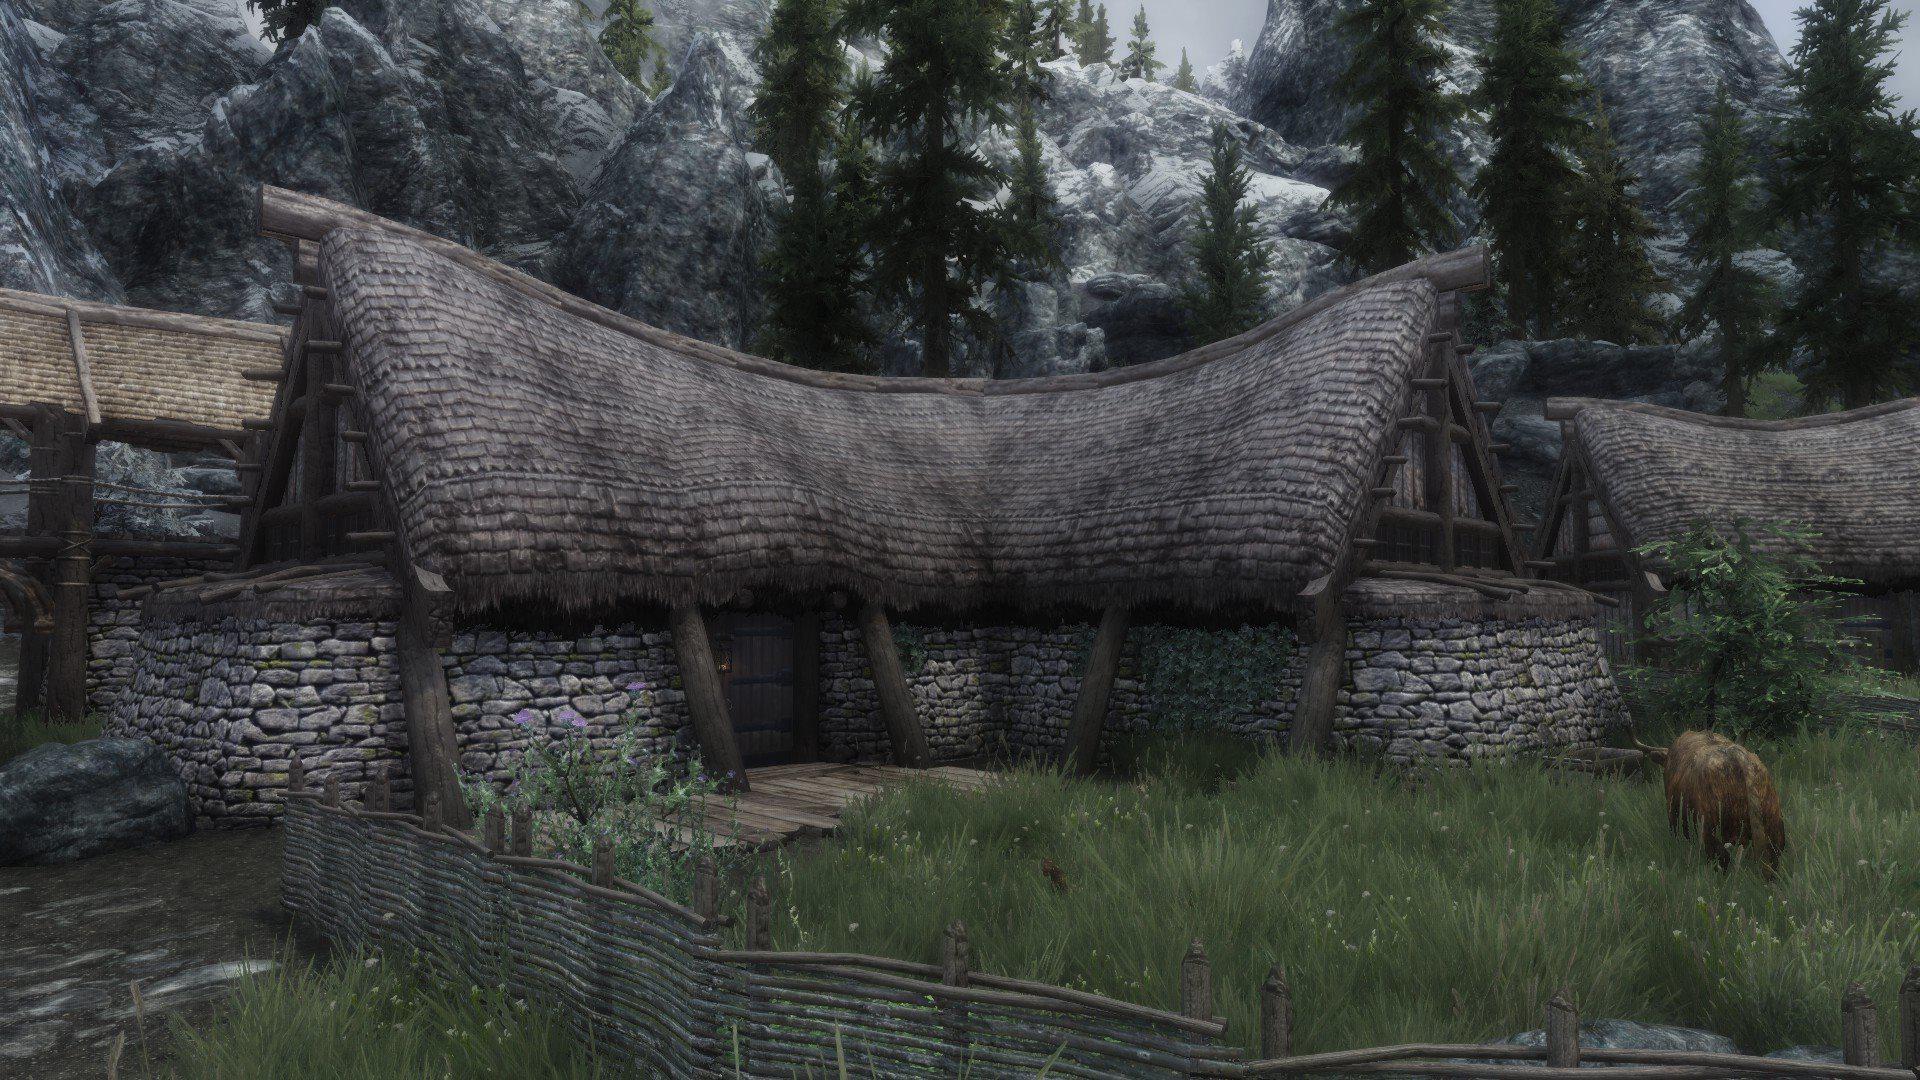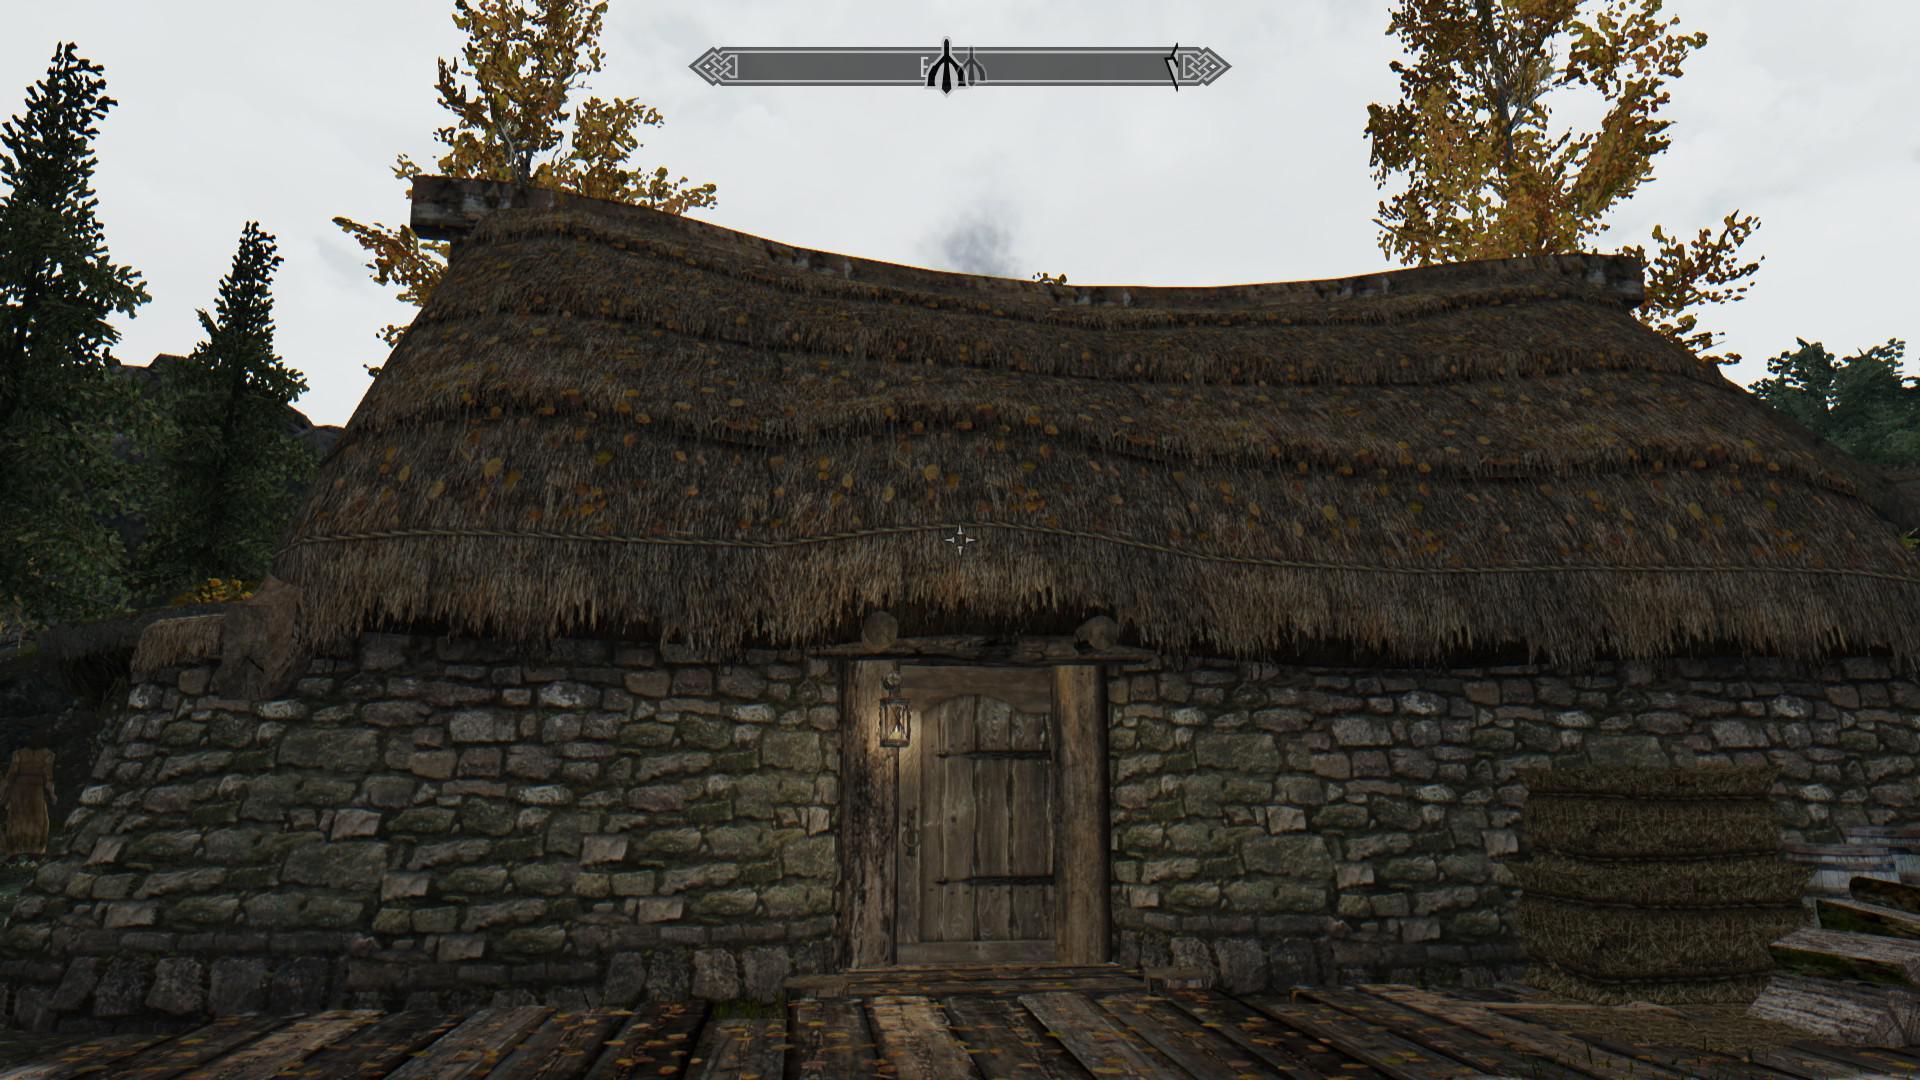The first image is the image on the left, the second image is the image on the right. Evaluate the accuracy of this statement regarding the images: "The left image features a house with multiple chimneys atop a dark gray roof with a scalloped border on top, and curving asymmetrical hedges in front.". Is it true? Answer yes or no. No. 